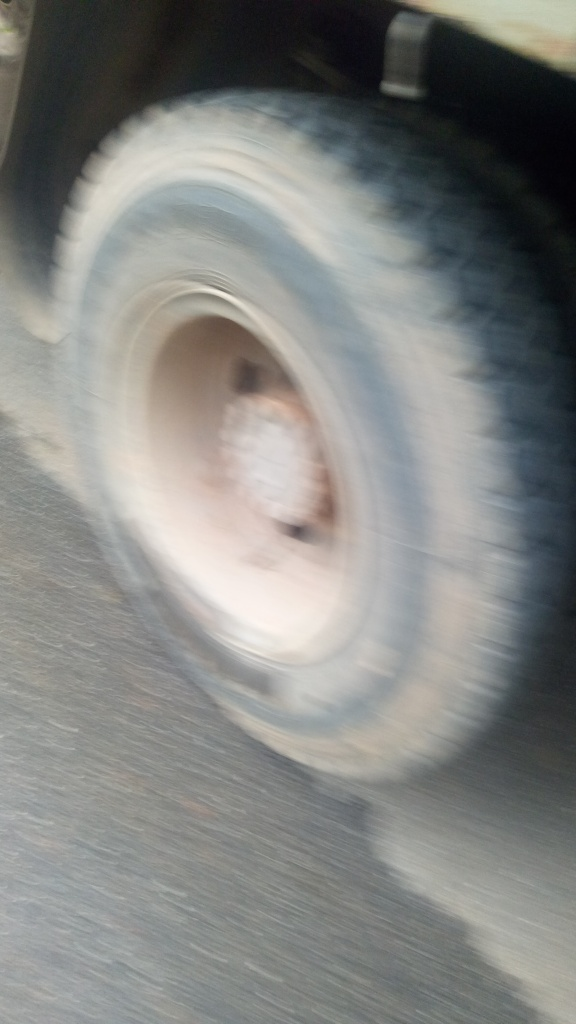What is the quality of this image?
A. Average
B. Very poor
C. Good
Answer with the option's letter from the given choices directly. The quality of this image is below average due to the significant blurring and lack of clear details, which suggests motion blur or a focus issue when the photograph was taken. While some images intentionally incorporate blur for artistic effect, this photograph appears to be unintentionally unclear. Therefore, a more descriptive answer would be option 'B', indicating that the quality is 'Very poor'. The lack of sharpness hinders the viewer's ability to appreciate or analyze the contents of the photo fully. 